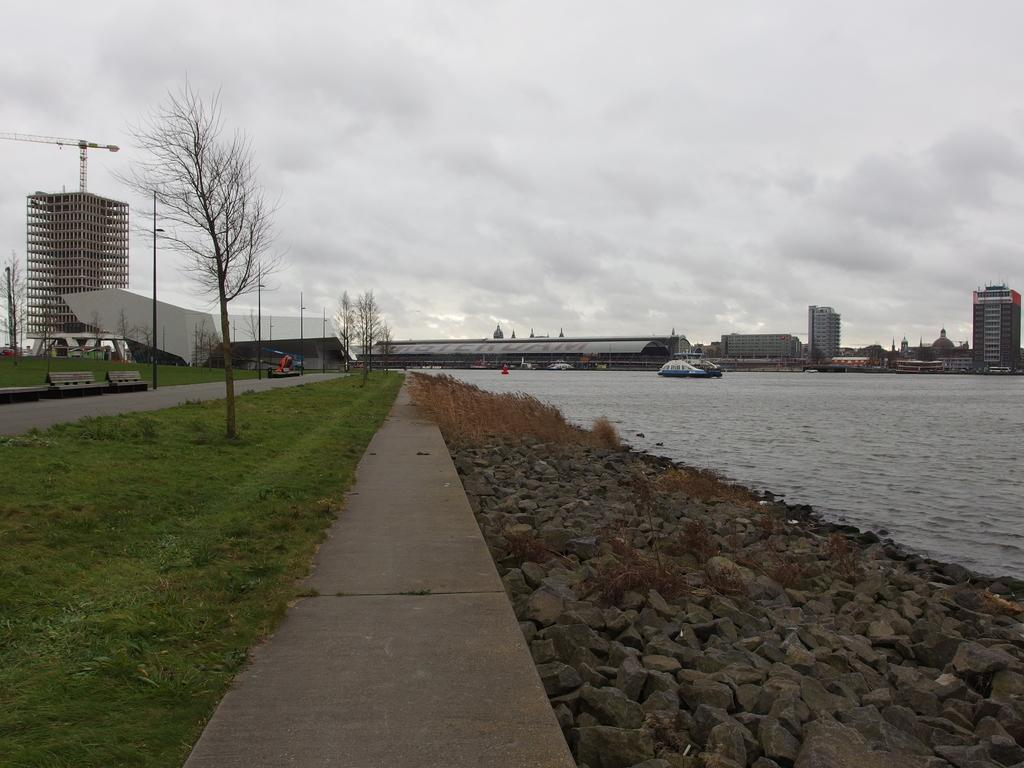What type of structures can be seen in the image? There are buildings in the image. What is located in the water in the image? There is a boat in the water. What type of vegetation is visible in the image? There is grass and trees visible in the image. What type of ground surface can be seen in the image? There are stones in the image. What is the condition of the sky in the image? The sky is cloudy in the image. Can you tell me how many apples are hanging from the trees in the image? There are no apples visible in the image; only trees are present. Is there a balloon floating in the sky in the image? There is no balloon present in the image; the sky is cloudy. 